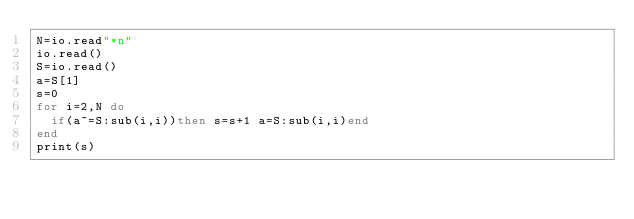Convert code to text. <code><loc_0><loc_0><loc_500><loc_500><_Lua_>N=io.read"*n"
io.read()
S=io.read()
a=S[1]
s=0
for i=2,N do
	if(a~=S:sub(i,i))then s=s+1 a=S:sub(i,i)end
end
print(s)</code> 